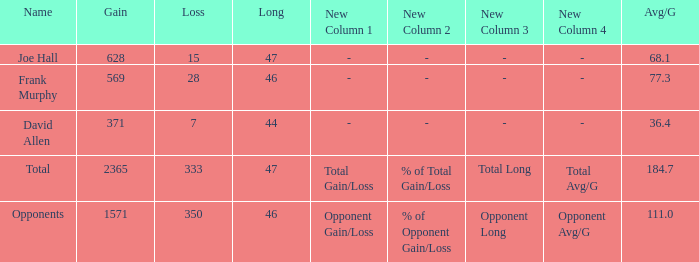How much Loss has a Gain smaller than 1571, and a Long smaller than 47, and an Avg/G of 36.4? 1.0. 